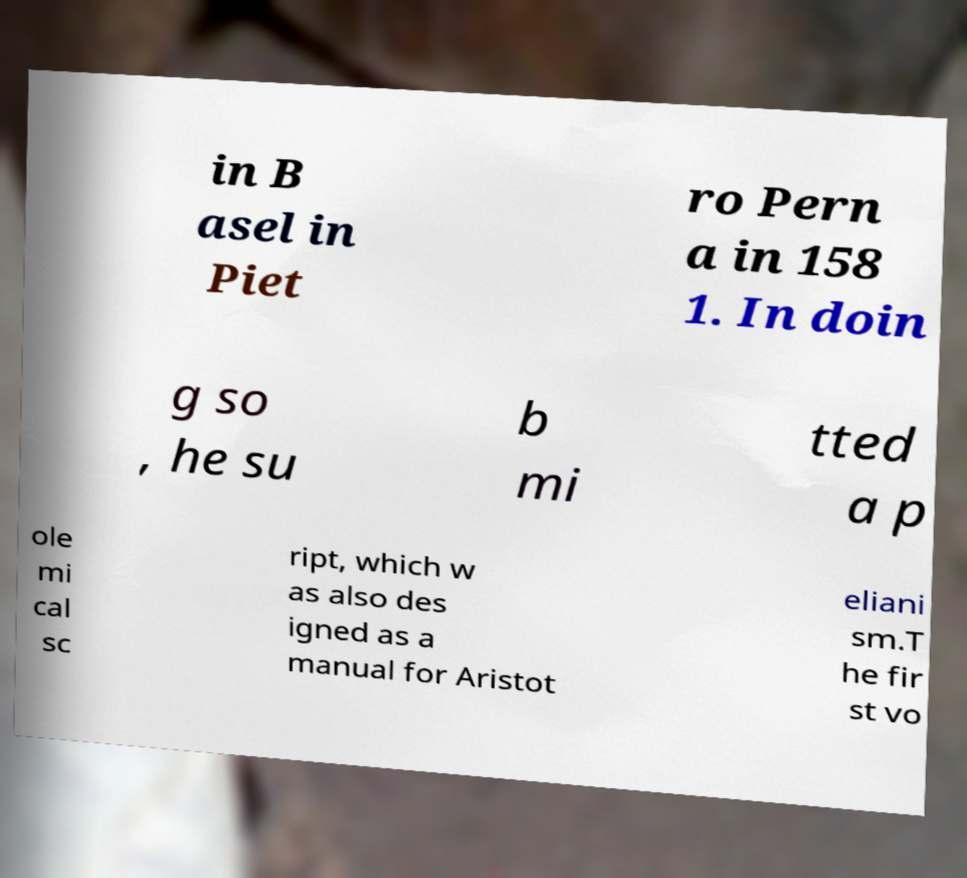Please identify and transcribe the text found in this image. in B asel in Piet ro Pern a in 158 1. In doin g so , he su b mi tted a p ole mi cal sc ript, which w as also des igned as a manual for Aristot eliani sm.T he fir st vo 